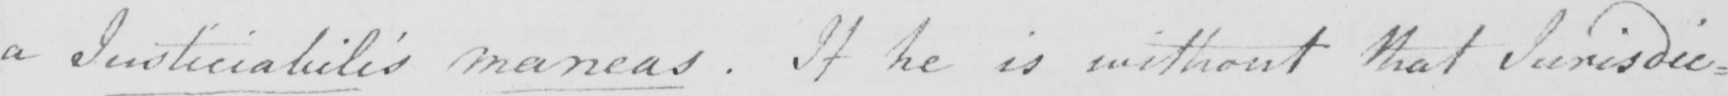Please provide the text content of this handwritten line. a Justiciabilis maneas . If he is without that Jurisdic : 